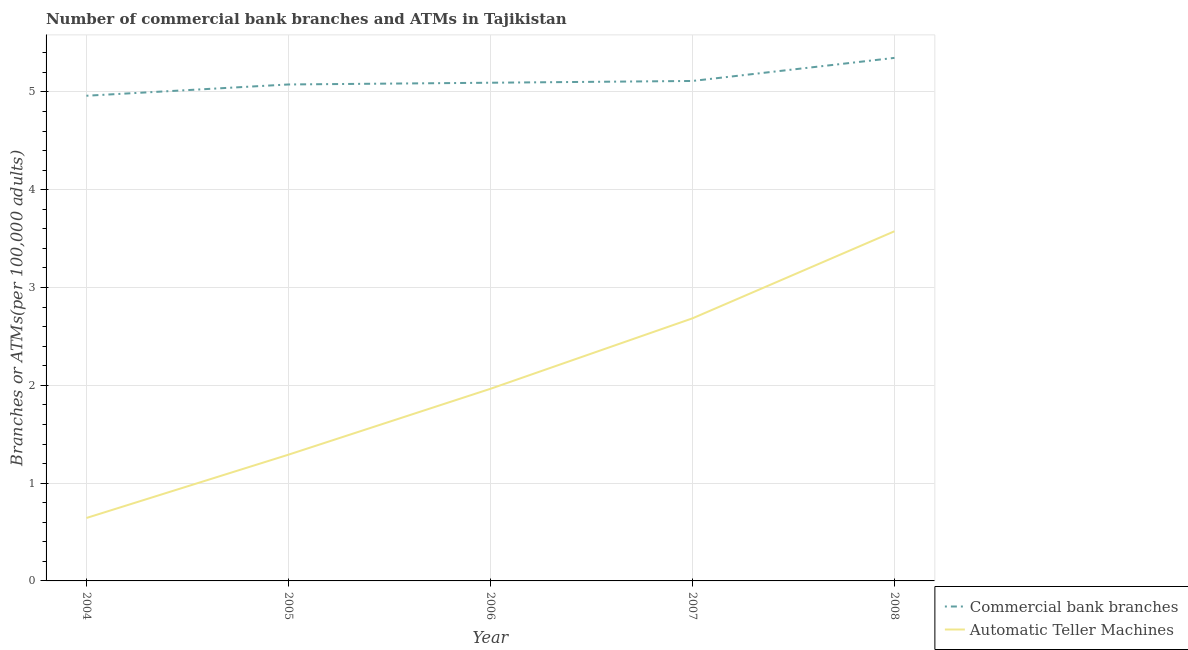What is the number of atms in 2006?
Keep it short and to the point. 1.96. Across all years, what is the maximum number of atms?
Give a very brief answer. 3.58. Across all years, what is the minimum number of atms?
Your answer should be very brief. 0.64. In which year was the number of atms maximum?
Keep it short and to the point. 2008. What is the total number of commercal bank branches in the graph?
Offer a very short reply. 25.59. What is the difference between the number of commercal bank branches in 2005 and that in 2007?
Provide a succinct answer. -0.04. What is the difference between the number of atms in 2005 and the number of commercal bank branches in 2008?
Make the answer very short. -4.06. What is the average number of commercal bank branches per year?
Offer a terse response. 5.12. In the year 2007, what is the difference between the number of atms and number of commercal bank branches?
Make the answer very short. -2.43. In how many years, is the number of commercal bank branches greater than 4.8?
Keep it short and to the point. 5. What is the ratio of the number of atms in 2006 to that in 2007?
Your response must be concise. 0.73. Is the number of atms in 2005 less than that in 2006?
Your response must be concise. Yes. What is the difference between the highest and the second highest number of commercal bank branches?
Your response must be concise. 0.24. What is the difference between the highest and the lowest number of atms?
Ensure brevity in your answer.  2.93. In how many years, is the number of atms greater than the average number of atms taken over all years?
Ensure brevity in your answer.  2. Is the number of atms strictly greater than the number of commercal bank branches over the years?
Make the answer very short. No. Is the number of atms strictly less than the number of commercal bank branches over the years?
Offer a very short reply. Yes. How many lines are there?
Offer a terse response. 2. What is the difference between two consecutive major ticks on the Y-axis?
Give a very brief answer. 1. Does the graph contain any zero values?
Your answer should be very brief. No. How are the legend labels stacked?
Give a very brief answer. Vertical. What is the title of the graph?
Your answer should be compact. Number of commercial bank branches and ATMs in Tajikistan. Does "Working only" appear as one of the legend labels in the graph?
Your response must be concise. No. What is the label or title of the X-axis?
Your answer should be compact. Year. What is the label or title of the Y-axis?
Make the answer very short. Branches or ATMs(per 100,0 adults). What is the Branches or ATMs(per 100,000 adults) in Commercial bank branches in 2004?
Provide a short and direct response. 4.96. What is the Branches or ATMs(per 100,000 adults) of Automatic Teller Machines in 2004?
Give a very brief answer. 0.64. What is the Branches or ATMs(per 100,000 adults) in Commercial bank branches in 2005?
Your answer should be compact. 5.08. What is the Branches or ATMs(per 100,000 adults) in Automatic Teller Machines in 2005?
Ensure brevity in your answer.  1.29. What is the Branches or ATMs(per 100,000 adults) of Commercial bank branches in 2006?
Your answer should be very brief. 5.09. What is the Branches or ATMs(per 100,000 adults) in Automatic Teller Machines in 2006?
Provide a short and direct response. 1.96. What is the Branches or ATMs(per 100,000 adults) in Commercial bank branches in 2007?
Your answer should be compact. 5.11. What is the Branches or ATMs(per 100,000 adults) in Automatic Teller Machines in 2007?
Make the answer very short. 2.69. What is the Branches or ATMs(per 100,000 adults) of Commercial bank branches in 2008?
Give a very brief answer. 5.35. What is the Branches or ATMs(per 100,000 adults) of Automatic Teller Machines in 2008?
Offer a very short reply. 3.58. Across all years, what is the maximum Branches or ATMs(per 100,000 adults) in Commercial bank branches?
Your response must be concise. 5.35. Across all years, what is the maximum Branches or ATMs(per 100,000 adults) in Automatic Teller Machines?
Give a very brief answer. 3.58. Across all years, what is the minimum Branches or ATMs(per 100,000 adults) of Commercial bank branches?
Make the answer very short. 4.96. Across all years, what is the minimum Branches or ATMs(per 100,000 adults) in Automatic Teller Machines?
Give a very brief answer. 0.64. What is the total Branches or ATMs(per 100,000 adults) in Commercial bank branches in the graph?
Your response must be concise. 25.59. What is the total Branches or ATMs(per 100,000 adults) of Automatic Teller Machines in the graph?
Your response must be concise. 10.16. What is the difference between the Branches or ATMs(per 100,000 adults) of Commercial bank branches in 2004 and that in 2005?
Your answer should be very brief. -0.12. What is the difference between the Branches or ATMs(per 100,000 adults) of Automatic Teller Machines in 2004 and that in 2005?
Provide a succinct answer. -0.65. What is the difference between the Branches or ATMs(per 100,000 adults) in Commercial bank branches in 2004 and that in 2006?
Your response must be concise. -0.13. What is the difference between the Branches or ATMs(per 100,000 adults) in Automatic Teller Machines in 2004 and that in 2006?
Provide a short and direct response. -1.32. What is the difference between the Branches or ATMs(per 100,000 adults) of Commercial bank branches in 2004 and that in 2007?
Your response must be concise. -0.15. What is the difference between the Branches or ATMs(per 100,000 adults) of Automatic Teller Machines in 2004 and that in 2007?
Your answer should be very brief. -2.04. What is the difference between the Branches or ATMs(per 100,000 adults) of Commercial bank branches in 2004 and that in 2008?
Your answer should be very brief. -0.39. What is the difference between the Branches or ATMs(per 100,000 adults) of Automatic Teller Machines in 2004 and that in 2008?
Provide a succinct answer. -2.93. What is the difference between the Branches or ATMs(per 100,000 adults) of Commercial bank branches in 2005 and that in 2006?
Keep it short and to the point. -0.02. What is the difference between the Branches or ATMs(per 100,000 adults) in Automatic Teller Machines in 2005 and that in 2006?
Ensure brevity in your answer.  -0.67. What is the difference between the Branches or ATMs(per 100,000 adults) of Commercial bank branches in 2005 and that in 2007?
Offer a very short reply. -0.04. What is the difference between the Branches or ATMs(per 100,000 adults) in Automatic Teller Machines in 2005 and that in 2007?
Your answer should be compact. -1.39. What is the difference between the Branches or ATMs(per 100,000 adults) of Commercial bank branches in 2005 and that in 2008?
Provide a succinct answer. -0.27. What is the difference between the Branches or ATMs(per 100,000 adults) in Automatic Teller Machines in 2005 and that in 2008?
Provide a short and direct response. -2.28. What is the difference between the Branches or ATMs(per 100,000 adults) of Commercial bank branches in 2006 and that in 2007?
Your answer should be compact. -0.02. What is the difference between the Branches or ATMs(per 100,000 adults) of Automatic Teller Machines in 2006 and that in 2007?
Offer a very short reply. -0.72. What is the difference between the Branches or ATMs(per 100,000 adults) of Commercial bank branches in 2006 and that in 2008?
Make the answer very short. -0.25. What is the difference between the Branches or ATMs(per 100,000 adults) in Automatic Teller Machines in 2006 and that in 2008?
Your answer should be very brief. -1.61. What is the difference between the Branches or ATMs(per 100,000 adults) in Commercial bank branches in 2007 and that in 2008?
Provide a short and direct response. -0.24. What is the difference between the Branches or ATMs(per 100,000 adults) in Automatic Teller Machines in 2007 and that in 2008?
Your answer should be very brief. -0.89. What is the difference between the Branches or ATMs(per 100,000 adults) in Commercial bank branches in 2004 and the Branches or ATMs(per 100,000 adults) in Automatic Teller Machines in 2005?
Keep it short and to the point. 3.67. What is the difference between the Branches or ATMs(per 100,000 adults) of Commercial bank branches in 2004 and the Branches or ATMs(per 100,000 adults) of Automatic Teller Machines in 2006?
Offer a terse response. 3. What is the difference between the Branches or ATMs(per 100,000 adults) of Commercial bank branches in 2004 and the Branches or ATMs(per 100,000 adults) of Automatic Teller Machines in 2007?
Your answer should be compact. 2.28. What is the difference between the Branches or ATMs(per 100,000 adults) of Commercial bank branches in 2004 and the Branches or ATMs(per 100,000 adults) of Automatic Teller Machines in 2008?
Give a very brief answer. 1.39. What is the difference between the Branches or ATMs(per 100,000 adults) in Commercial bank branches in 2005 and the Branches or ATMs(per 100,000 adults) in Automatic Teller Machines in 2006?
Offer a terse response. 3.11. What is the difference between the Branches or ATMs(per 100,000 adults) of Commercial bank branches in 2005 and the Branches or ATMs(per 100,000 adults) of Automatic Teller Machines in 2007?
Your answer should be compact. 2.39. What is the difference between the Branches or ATMs(per 100,000 adults) in Commercial bank branches in 2005 and the Branches or ATMs(per 100,000 adults) in Automatic Teller Machines in 2008?
Give a very brief answer. 1.5. What is the difference between the Branches or ATMs(per 100,000 adults) in Commercial bank branches in 2006 and the Branches or ATMs(per 100,000 adults) in Automatic Teller Machines in 2007?
Provide a short and direct response. 2.41. What is the difference between the Branches or ATMs(per 100,000 adults) in Commercial bank branches in 2006 and the Branches or ATMs(per 100,000 adults) in Automatic Teller Machines in 2008?
Provide a short and direct response. 1.52. What is the difference between the Branches or ATMs(per 100,000 adults) in Commercial bank branches in 2007 and the Branches or ATMs(per 100,000 adults) in Automatic Teller Machines in 2008?
Offer a terse response. 1.54. What is the average Branches or ATMs(per 100,000 adults) of Commercial bank branches per year?
Keep it short and to the point. 5.12. What is the average Branches or ATMs(per 100,000 adults) in Automatic Teller Machines per year?
Your answer should be compact. 2.03. In the year 2004, what is the difference between the Branches or ATMs(per 100,000 adults) in Commercial bank branches and Branches or ATMs(per 100,000 adults) in Automatic Teller Machines?
Ensure brevity in your answer.  4.32. In the year 2005, what is the difference between the Branches or ATMs(per 100,000 adults) in Commercial bank branches and Branches or ATMs(per 100,000 adults) in Automatic Teller Machines?
Keep it short and to the point. 3.79. In the year 2006, what is the difference between the Branches or ATMs(per 100,000 adults) in Commercial bank branches and Branches or ATMs(per 100,000 adults) in Automatic Teller Machines?
Your answer should be compact. 3.13. In the year 2007, what is the difference between the Branches or ATMs(per 100,000 adults) of Commercial bank branches and Branches or ATMs(per 100,000 adults) of Automatic Teller Machines?
Your answer should be very brief. 2.43. In the year 2008, what is the difference between the Branches or ATMs(per 100,000 adults) of Commercial bank branches and Branches or ATMs(per 100,000 adults) of Automatic Teller Machines?
Give a very brief answer. 1.77. What is the ratio of the Branches or ATMs(per 100,000 adults) in Commercial bank branches in 2004 to that in 2005?
Offer a very short reply. 0.98. What is the ratio of the Branches or ATMs(per 100,000 adults) of Automatic Teller Machines in 2004 to that in 2005?
Give a very brief answer. 0.5. What is the ratio of the Branches or ATMs(per 100,000 adults) of Commercial bank branches in 2004 to that in 2006?
Give a very brief answer. 0.97. What is the ratio of the Branches or ATMs(per 100,000 adults) in Automatic Teller Machines in 2004 to that in 2006?
Your response must be concise. 0.33. What is the ratio of the Branches or ATMs(per 100,000 adults) in Commercial bank branches in 2004 to that in 2007?
Provide a succinct answer. 0.97. What is the ratio of the Branches or ATMs(per 100,000 adults) of Automatic Teller Machines in 2004 to that in 2007?
Offer a very short reply. 0.24. What is the ratio of the Branches or ATMs(per 100,000 adults) in Commercial bank branches in 2004 to that in 2008?
Your answer should be very brief. 0.93. What is the ratio of the Branches or ATMs(per 100,000 adults) of Automatic Teller Machines in 2004 to that in 2008?
Keep it short and to the point. 0.18. What is the ratio of the Branches or ATMs(per 100,000 adults) of Automatic Teller Machines in 2005 to that in 2006?
Your answer should be very brief. 0.66. What is the ratio of the Branches or ATMs(per 100,000 adults) in Commercial bank branches in 2005 to that in 2007?
Make the answer very short. 0.99. What is the ratio of the Branches or ATMs(per 100,000 adults) in Automatic Teller Machines in 2005 to that in 2007?
Offer a very short reply. 0.48. What is the ratio of the Branches or ATMs(per 100,000 adults) in Commercial bank branches in 2005 to that in 2008?
Your answer should be very brief. 0.95. What is the ratio of the Branches or ATMs(per 100,000 adults) in Automatic Teller Machines in 2005 to that in 2008?
Offer a very short reply. 0.36. What is the ratio of the Branches or ATMs(per 100,000 adults) in Commercial bank branches in 2006 to that in 2007?
Give a very brief answer. 1. What is the ratio of the Branches or ATMs(per 100,000 adults) in Automatic Teller Machines in 2006 to that in 2007?
Provide a short and direct response. 0.73. What is the ratio of the Branches or ATMs(per 100,000 adults) of Commercial bank branches in 2006 to that in 2008?
Offer a very short reply. 0.95. What is the ratio of the Branches or ATMs(per 100,000 adults) in Automatic Teller Machines in 2006 to that in 2008?
Ensure brevity in your answer.  0.55. What is the ratio of the Branches or ATMs(per 100,000 adults) in Commercial bank branches in 2007 to that in 2008?
Provide a succinct answer. 0.96. What is the ratio of the Branches or ATMs(per 100,000 adults) of Automatic Teller Machines in 2007 to that in 2008?
Offer a terse response. 0.75. What is the difference between the highest and the second highest Branches or ATMs(per 100,000 adults) of Commercial bank branches?
Your answer should be very brief. 0.24. What is the difference between the highest and the second highest Branches or ATMs(per 100,000 adults) in Automatic Teller Machines?
Ensure brevity in your answer.  0.89. What is the difference between the highest and the lowest Branches or ATMs(per 100,000 adults) in Commercial bank branches?
Your response must be concise. 0.39. What is the difference between the highest and the lowest Branches or ATMs(per 100,000 adults) of Automatic Teller Machines?
Ensure brevity in your answer.  2.93. 